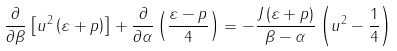Convert formula to latex. <formula><loc_0><loc_0><loc_500><loc_500>\frac { \partial } { \partial \beta } \left [ { u ^ { 2 } \left ( { \varepsilon + p } \right ) } \right ] + \frac { \partial } { \partial \alpha } \left ( { \frac { \varepsilon - p } { 4 } } \right ) = - \frac { J \left ( { \varepsilon + p } \right ) } { \beta - \alpha } \left ( { u ^ { 2 } - \frac { 1 } { 4 } } \right )</formula> 